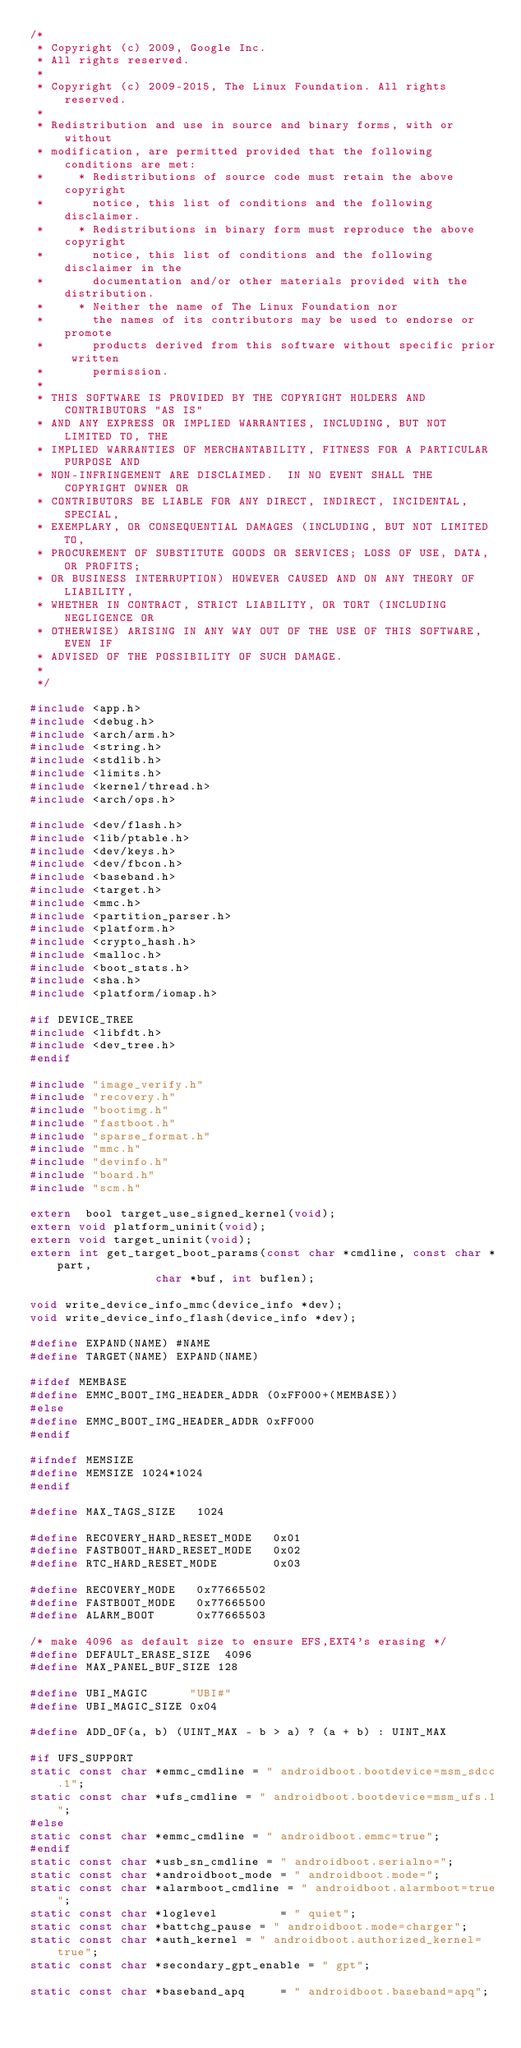Convert code to text. <code><loc_0><loc_0><loc_500><loc_500><_C_>/*
 * Copyright (c) 2009, Google Inc.
 * All rights reserved.
 *
 * Copyright (c) 2009-2015, The Linux Foundation. All rights reserved.
 *
 * Redistribution and use in source and binary forms, with or without
 * modification, are permitted provided that the following conditions are met:
 *     * Redistributions of source code must retain the above copyright
 *       notice, this list of conditions and the following disclaimer.
 *     * Redistributions in binary form must reproduce the above copyright
 *       notice, this list of conditions and the following disclaimer in the
 *       documentation and/or other materials provided with the distribution.
 *     * Neither the name of The Linux Foundation nor
 *       the names of its contributors may be used to endorse or promote
 *       products derived from this software without specific prior written
 *       permission.
 *
 * THIS SOFTWARE IS PROVIDED BY THE COPYRIGHT HOLDERS AND CONTRIBUTORS "AS IS"
 * AND ANY EXPRESS OR IMPLIED WARRANTIES, INCLUDING, BUT NOT LIMITED TO, THE
 * IMPLIED WARRANTIES OF MERCHANTABILITY, FITNESS FOR A PARTICULAR PURPOSE AND
 * NON-INFRINGEMENT ARE DISCLAIMED.  IN NO EVENT SHALL THE COPYRIGHT OWNER OR
 * CONTRIBUTORS BE LIABLE FOR ANY DIRECT, INDIRECT, INCIDENTAL, SPECIAL,
 * EXEMPLARY, OR CONSEQUENTIAL DAMAGES (INCLUDING, BUT NOT LIMITED TO,
 * PROCUREMENT OF SUBSTITUTE GOODS OR SERVICES; LOSS OF USE, DATA, OR PROFITS;
 * OR BUSINESS INTERRUPTION) HOWEVER CAUSED AND ON ANY THEORY OF LIABILITY,
 * WHETHER IN CONTRACT, STRICT LIABILITY, OR TORT (INCLUDING NEGLIGENCE OR
 * OTHERWISE) ARISING IN ANY WAY OUT OF THE USE OF THIS SOFTWARE, EVEN IF
 * ADVISED OF THE POSSIBILITY OF SUCH DAMAGE.
 *
 */

#include <app.h>
#include <debug.h>
#include <arch/arm.h>
#include <string.h>
#include <stdlib.h>
#include <limits.h>
#include <kernel/thread.h>
#include <arch/ops.h>

#include <dev/flash.h>
#include <lib/ptable.h>
#include <dev/keys.h>
#include <dev/fbcon.h>
#include <baseband.h>
#include <target.h>
#include <mmc.h>
#include <partition_parser.h>
#include <platform.h>
#include <crypto_hash.h>
#include <malloc.h>
#include <boot_stats.h>
#include <sha.h>
#include <platform/iomap.h>

#if DEVICE_TREE
#include <libfdt.h>
#include <dev_tree.h>
#endif

#include "image_verify.h"
#include "recovery.h"
#include "bootimg.h"
#include "fastboot.h"
#include "sparse_format.h"
#include "mmc.h"
#include "devinfo.h"
#include "board.h"
#include "scm.h"

extern  bool target_use_signed_kernel(void);
extern void platform_uninit(void);
extern void target_uninit(void);
extern int get_target_boot_params(const char *cmdline, const char *part,
				  char *buf, int buflen);

void write_device_info_mmc(device_info *dev);
void write_device_info_flash(device_info *dev);

#define EXPAND(NAME) #NAME
#define TARGET(NAME) EXPAND(NAME)

#ifdef MEMBASE
#define EMMC_BOOT_IMG_HEADER_ADDR (0xFF000+(MEMBASE))
#else
#define EMMC_BOOT_IMG_HEADER_ADDR 0xFF000
#endif

#ifndef MEMSIZE
#define MEMSIZE 1024*1024
#endif

#define MAX_TAGS_SIZE   1024

#define RECOVERY_HARD_RESET_MODE   0x01
#define FASTBOOT_HARD_RESET_MODE   0x02
#define RTC_HARD_RESET_MODE        0x03

#define RECOVERY_MODE   0x77665502
#define FASTBOOT_MODE   0x77665500
#define ALARM_BOOT      0x77665503

/* make 4096 as default size to ensure EFS,EXT4's erasing */
#define DEFAULT_ERASE_SIZE  4096
#define MAX_PANEL_BUF_SIZE 128

#define UBI_MAGIC      "UBI#"
#define UBI_MAGIC_SIZE 0x04

#define ADD_OF(a, b) (UINT_MAX - b > a) ? (a + b) : UINT_MAX

#if UFS_SUPPORT
static const char *emmc_cmdline = " androidboot.bootdevice=msm_sdcc.1";
static const char *ufs_cmdline = " androidboot.bootdevice=msm_ufs.1";
#else
static const char *emmc_cmdline = " androidboot.emmc=true";
#endif
static const char *usb_sn_cmdline = " androidboot.serialno=";
static const char *androidboot_mode = " androidboot.mode=";
static const char *alarmboot_cmdline = " androidboot.alarmboot=true";
static const char *loglevel         = " quiet";
static const char *battchg_pause = " androidboot.mode=charger";
static const char *auth_kernel = " androidboot.authorized_kernel=true";
static const char *secondary_gpt_enable = " gpt";

static const char *baseband_apq     = " androidboot.baseband=apq";</code> 